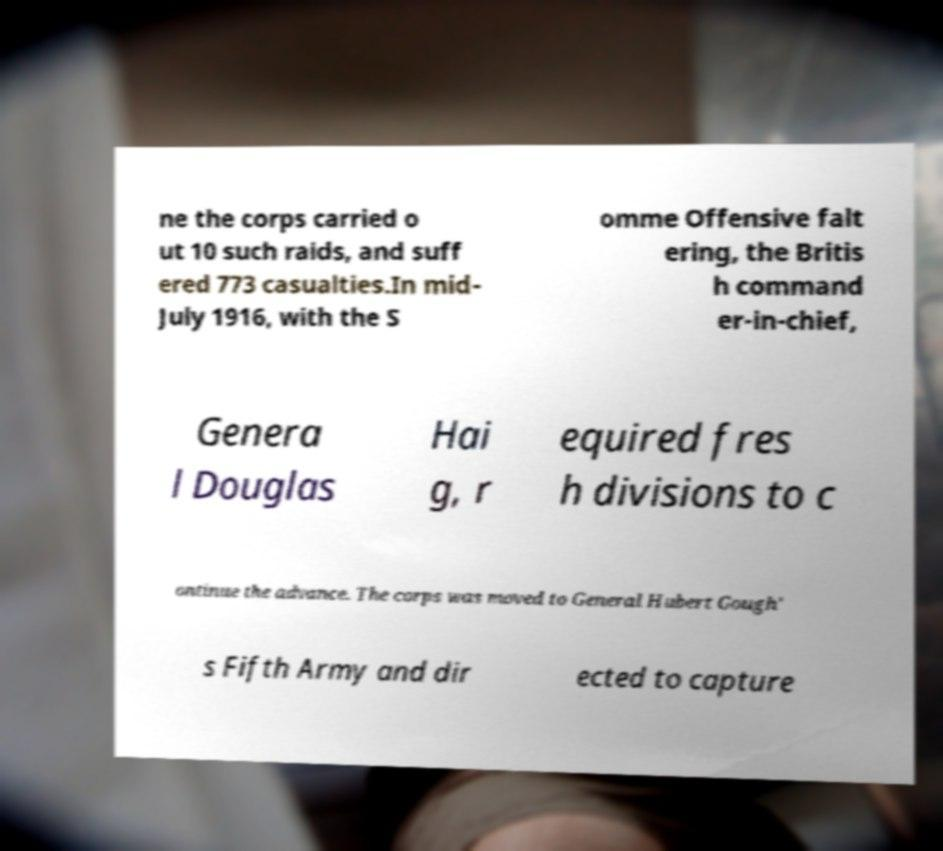I need the written content from this picture converted into text. Can you do that? ne the corps carried o ut 10 such raids, and suff ered 773 casualties.In mid- July 1916, with the S omme Offensive falt ering, the Britis h command er-in-chief, Genera l Douglas Hai g, r equired fres h divisions to c ontinue the advance. The corps was moved to General Hubert Gough' s Fifth Army and dir ected to capture 